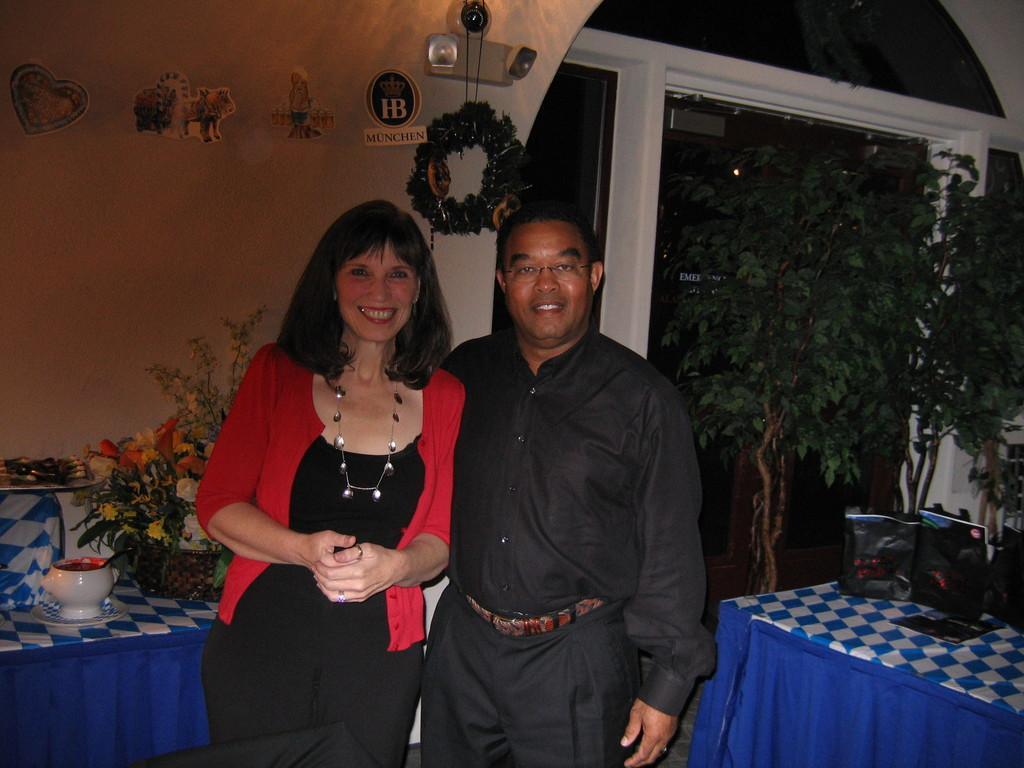How would you summarize this image in a sentence or two? In this picture, There are some tables which are in blue color and in the middle there are two people standing and in the background there is a white color wall and there are some green color plants. 